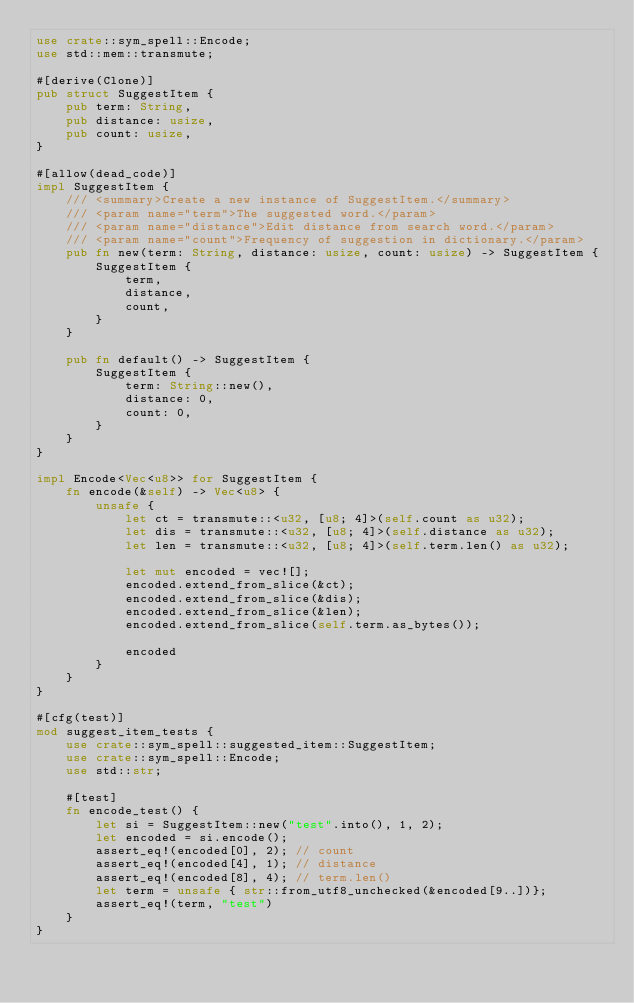<code> <loc_0><loc_0><loc_500><loc_500><_Rust_>use crate::sym_spell::Encode;
use std::mem::transmute;

#[derive(Clone)]
pub struct SuggestItem {
    pub term: String,
    pub distance: usize,
    pub count: usize,
}

#[allow(dead_code)]
impl SuggestItem {
    /// <summary>Create a new instance of SuggestItem.</summary>
    /// <param name="term">The suggested word.</param>
    /// <param name="distance">Edit distance from search word.</param>
    /// <param name="count">Frequency of suggestion in dictionary.</param>
    pub fn new(term: String, distance: usize, count: usize) -> SuggestItem {
        SuggestItem {
            term,
            distance,
            count,
        }
    }

    pub fn default() -> SuggestItem {
        SuggestItem {
            term: String::new(),
            distance: 0,
            count: 0,
        }
    }
}

impl Encode<Vec<u8>> for SuggestItem {
    fn encode(&self) -> Vec<u8> {
        unsafe {
            let ct = transmute::<u32, [u8; 4]>(self.count as u32);
            let dis = transmute::<u32, [u8; 4]>(self.distance as u32);
            let len = transmute::<u32, [u8; 4]>(self.term.len() as u32);

            let mut encoded = vec![];
            encoded.extend_from_slice(&ct);
            encoded.extend_from_slice(&dis);
            encoded.extend_from_slice(&len);
            encoded.extend_from_slice(self.term.as_bytes());

            encoded
        }
    }
}

#[cfg(test)]
mod suggest_item_tests {
    use crate::sym_spell::suggested_item::SuggestItem;
    use crate::sym_spell::Encode;
    use std::str;

    #[test]
    fn encode_test() {
        let si = SuggestItem::new("test".into(), 1, 2);
        let encoded = si.encode();
        assert_eq!(encoded[0], 2); // count
        assert_eq!(encoded[4], 1); // distance
        assert_eq!(encoded[8], 4); // term.len()
        let term = unsafe { str::from_utf8_unchecked(&encoded[9..])};
        assert_eq!(term, "test")
    }
}</code> 